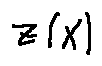<formula> <loc_0><loc_0><loc_500><loc_500>z ( X )</formula> 